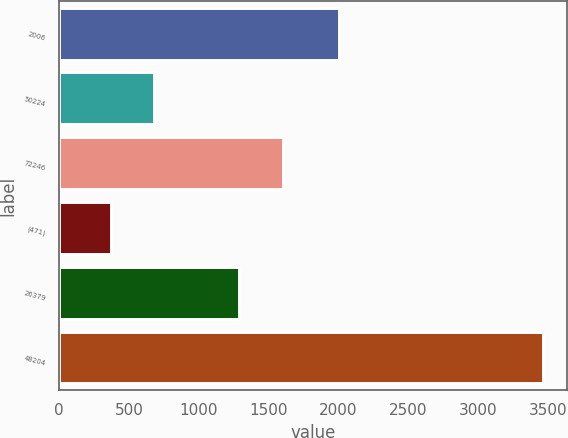Convert chart. <chart><loc_0><loc_0><loc_500><loc_500><bar_chart><fcel>2006<fcel>50224<fcel>72246<fcel>(471)<fcel>26379<fcel>48204<nl><fcel>2006<fcel>680.3<fcel>1600.3<fcel>371<fcel>1291<fcel>3464<nl></chart> 